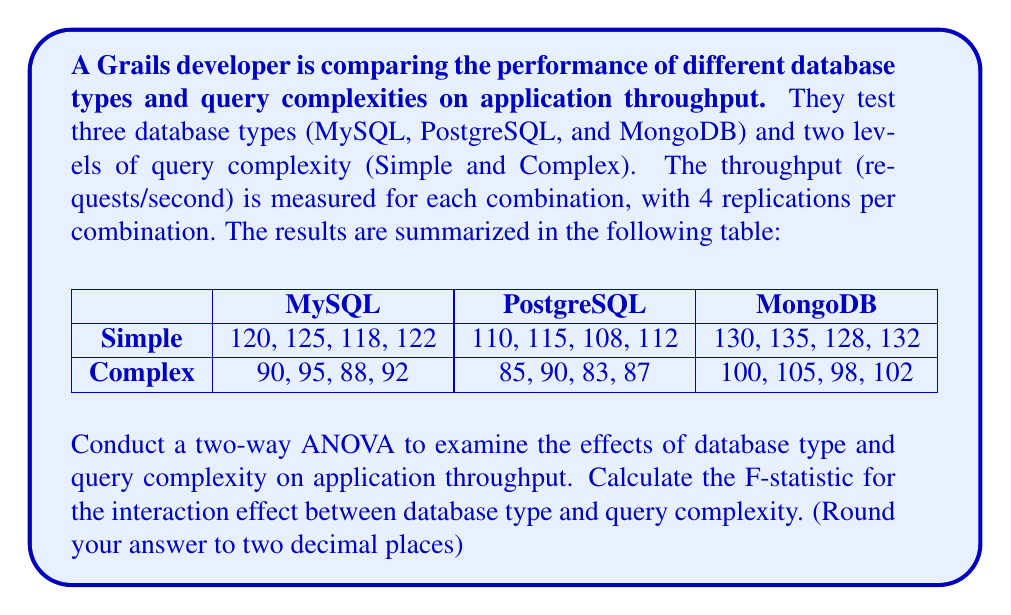Could you help me with this problem? To conduct a two-way ANOVA and calculate the F-statistic for the interaction effect, we'll follow these steps:

1. Calculate the total sum of squares (SST)
2. Calculate the sum of squares for database type (SSA)
3. Calculate the sum of squares for query complexity (SSB)
4. Calculate the sum of squares for interaction (SSAB)
5. Calculate the sum of squares for error (SSE)
6. Calculate the degrees of freedom
7. Calculate the mean squares
8. Calculate the F-statistic for interaction

Step 1: Calculate SST
First, we need to calculate the grand mean and SST.

Grand mean = (Sum of all observations) / (Total number of observations)
$$ \bar{X} = \frac{2600}{24} = 108.33 $$

SST = Sum of squared deviations from the grand mean
$$ SST = \sum (X - \bar{X})^2 = 10,866.67 $$

Step 2: Calculate SSA (Database Type)
Calculate the sum of squares for database type:
$$ SSA = 4 \times 2 \times \sum_{i=1}^{3} (\bar{X_i} - \bar{X})^2 = 2,816.67 $$

Step 3: Calculate SSB (Query Complexity)
Calculate the sum of squares for query complexity:
$$ SSB = 4 \times 3 \times \sum_{j=1}^{2} (\bar{X_j} - \bar{X})^2 = 7,704.17 $$

Step 4: Calculate SSAB (Interaction)
Calculate the sum of squares for interaction:
$$ SSAB = 4 \times \sum_{i=1}^{3} \sum_{j=1}^{2} (\bar{X_{ij}} - \bar{X_i} - \bar{X_j} + \bar{X})^2 = 16.67 $$

Step 5: Calculate SSE (Error)
$$ SSE = SST - SSA - SSB - SSAB = 329.16 $$

Step 6: Calculate degrees of freedom
- Database Type (df_A) = 3 - 1 = 2
- Query Complexity (df_B) = 2 - 1 = 1
- Interaction (df_AB) = df_A × df_B = 2
- Error (df_E) = 24 - (3 × 2) = 18
- Total (df_T) = 24 - 1 = 23

Step 7: Calculate mean squares
$$ MS_{AB} = \frac{SSAB}{df_{AB}} = \frac{16.67}{2} = 8.34 $$
$$ MS_E = \frac{SSE}{df_E} = \frac{329.16}{18} = 18.29 $$

Step 8: Calculate F-statistic for interaction
$$ F = \frac{MS_{AB}}{MS_E} = \frac{8.34}{18.29} = 0.46 $$

Rounding to two decimal places, we get 0.46.
Answer: 0.46 